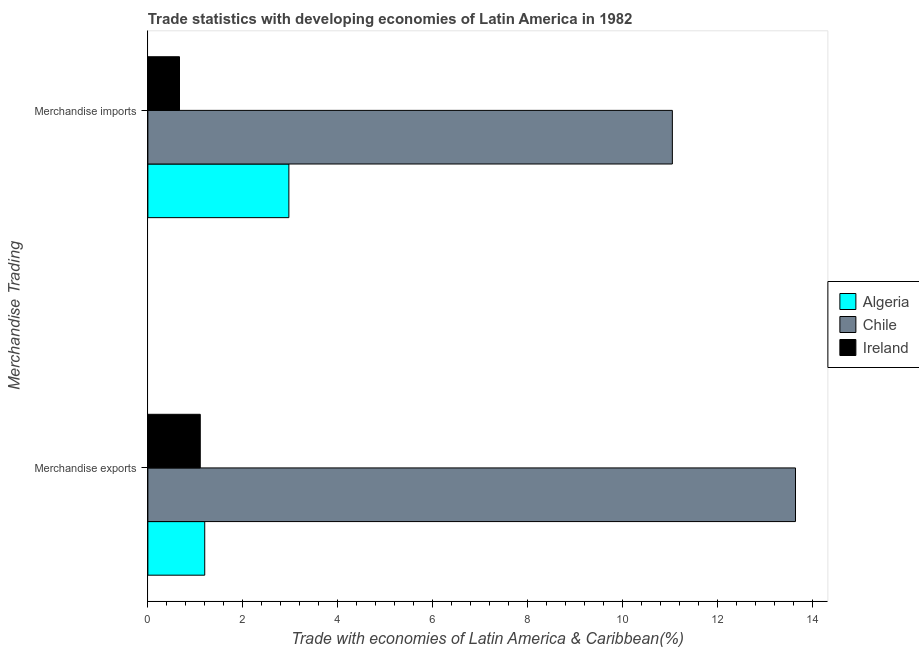How many different coloured bars are there?
Your response must be concise. 3. How many groups of bars are there?
Your answer should be very brief. 2. How many bars are there on the 1st tick from the bottom?
Provide a succinct answer. 3. What is the label of the 2nd group of bars from the top?
Give a very brief answer. Merchandise exports. What is the merchandise imports in Chile?
Your answer should be very brief. 11.05. Across all countries, what is the maximum merchandise exports?
Provide a succinct answer. 13.65. Across all countries, what is the minimum merchandise imports?
Give a very brief answer. 0.67. In which country was the merchandise exports minimum?
Offer a very short reply. Ireland. What is the total merchandise exports in the graph?
Ensure brevity in your answer.  15.95. What is the difference between the merchandise imports in Algeria and that in Chile?
Make the answer very short. -8.08. What is the difference between the merchandise imports in Algeria and the merchandise exports in Ireland?
Keep it short and to the point. 1.87. What is the average merchandise imports per country?
Your response must be concise. 4.9. What is the difference between the merchandise imports and merchandise exports in Ireland?
Provide a succinct answer. -0.44. What is the ratio of the merchandise exports in Chile to that in Ireland?
Make the answer very short. 12.36. What does the 1st bar from the top in Merchandise imports represents?
Keep it short and to the point. Ireland. What does the 3rd bar from the bottom in Merchandise imports represents?
Keep it short and to the point. Ireland. How many bars are there?
Give a very brief answer. 6. Are all the bars in the graph horizontal?
Your answer should be compact. Yes. Does the graph contain grids?
Ensure brevity in your answer.  No. Where does the legend appear in the graph?
Offer a very short reply. Center right. How many legend labels are there?
Keep it short and to the point. 3. What is the title of the graph?
Offer a very short reply. Trade statistics with developing economies of Latin America in 1982. Does "St. Vincent and the Grenadines" appear as one of the legend labels in the graph?
Give a very brief answer. No. What is the label or title of the X-axis?
Offer a very short reply. Trade with economies of Latin America & Caribbean(%). What is the label or title of the Y-axis?
Give a very brief answer. Merchandise Trading. What is the Trade with economies of Latin America & Caribbean(%) of Algeria in Merchandise exports?
Offer a very short reply. 1.2. What is the Trade with economies of Latin America & Caribbean(%) in Chile in Merchandise exports?
Provide a succinct answer. 13.65. What is the Trade with economies of Latin America & Caribbean(%) of Ireland in Merchandise exports?
Offer a terse response. 1.1. What is the Trade with economies of Latin America & Caribbean(%) in Algeria in Merchandise imports?
Your response must be concise. 2.97. What is the Trade with economies of Latin America & Caribbean(%) in Chile in Merchandise imports?
Give a very brief answer. 11.05. What is the Trade with economies of Latin America & Caribbean(%) of Ireland in Merchandise imports?
Offer a terse response. 0.67. Across all Merchandise Trading, what is the maximum Trade with economies of Latin America & Caribbean(%) of Algeria?
Keep it short and to the point. 2.97. Across all Merchandise Trading, what is the maximum Trade with economies of Latin America & Caribbean(%) in Chile?
Give a very brief answer. 13.65. Across all Merchandise Trading, what is the maximum Trade with economies of Latin America & Caribbean(%) in Ireland?
Offer a very short reply. 1.1. Across all Merchandise Trading, what is the minimum Trade with economies of Latin America & Caribbean(%) of Algeria?
Your answer should be very brief. 1.2. Across all Merchandise Trading, what is the minimum Trade with economies of Latin America & Caribbean(%) of Chile?
Provide a short and direct response. 11.05. Across all Merchandise Trading, what is the minimum Trade with economies of Latin America & Caribbean(%) of Ireland?
Offer a terse response. 0.67. What is the total Trade with economies of Latin America & Caribbean(%) of Algeria in the graph?
Provide a succinct answer. 4.17. What is the total Trade with economies of Latin America & Caribbean(%) in Chile in the graph?
Your answer should be very brief. 24.7. What is the total Trade with economies of Latin America & Caribbean(%) of Ireland in the graph?
Give a very brief answer. 1.77. What is the difference between the Trade with economies of Latin America & Caribbean(%) of Algeria in Merchandise exports and that in Merchandise imports?
Provide a short and direct response. -1.77. What is the difference between the Trade with economies of Latin America & Caribbean(%) in Chile in Merchandise exports and that in Merchandise imports?
Your response must be concise. 2.6. What is the difference between the Trade with economies of Latin America & Caribbean(%) in Ireland in Merchandise exports and that in Merchandise imports?
Ensure brevity in your answer.  0.44. What is the difference between the Trade with economies of Latin America & Caribbean(%) of Algeria in Merchandise exports and the Trade with economies of Latin America & Caribbean(%) of Chile in Merchandise imports?
Your response must be concise. -9.86. What is the difference between the Trade with economies of Latin America & Caribbean(%) in Algeria in Merchandise exports and the Trade with economies of Latin America & Caribbean(%) in Ireland in Merchandise imports?
Give a very brief answer. 0.53. What is the difference between the Trade with economies of Latin America & Caribbean(%) of Chile in Merchandise exports and the Trade with economies of Latin America & Caribbean(%) of Ireland in Merchandise imports?
Your response must be concise. 12.98. What is the average Trade with economies of Latin America & Caribbean(%) of Algeria per Merchandise Trading?
Your answer should be compact. 2.09. What is the average Trade with economies of Latin America & Caribbean(%) of Chile per Merchandise Trading?
Offer a terse response. 12.35. What is the average Trade with economies of Latin America & Caribbean(%) in Ireland per Merchandise Trading?
Your answer should be compact. 0.89. What is the difference between the Trade with economies of Latin America & Caribbean(%) in Algeria and Trade with economies of Latin America & Caribbean(%) in Chile in Merchandise exports?
Offer a terse response. -12.45. What is the difference between the Trade with economies of Latin America & Caribbean(%) in Algeria and Trade with economies of Latin America & Caribbean(%) in Ireland in Merchandise exports?
Your response must be concise. 0.09. What is the difference between the Trade with economies of Latin America & Caribbean(%) of Chile and Trade with economies of Latin America & Caribbean(%) of Ireland in Merchandise exports?
Give a very brief answer. 12.55. What is the difference between the Trade with economies of Latin America & Caribbean(%) in Algeria and Trade with economies of Latin America & Caribbean(%) in Chile in Merchandise imports?
Offer a terse response. -8.08. What is the difference between the Trade with economies of Latin America & Caribbean(%) in Algeria and Trade with economies of Latin America & Caribbean(%) in Ireland in Merchandise imports?
Give a very brief answer. 2.31. What is the difference between the Trade with economies of Latin America & Caribbean(%) of Chile and Trade with economies of Latin America & Caribbean(%) of Ireland in Merchandise imports?
Provide a short and direct response. 10.39. What is the ratio of the Trade with economies of Latin America & Caribbean(%) in Algeria in Merchandise exports to that in Merchandise imports?
Provide a short and direct response. 0.4. What is the ratio of the Trade with economies of Latin America & Caribbean(%) of Chile in Merchandise exports to that in Merchandise imports?
Give a very brief answer. 1.23. What is the ratio of the Trade with economies of Latin America & Caribbean(%) in Ireland in Merchandise exports to that in Merchandise imports?
Offer a terse response. 1.66. What is the difference between the highest and the second highest Trade with economies of Latin America & Caribbean(%) of Algeria?
Ensure brevity in your answer.  1.77. What is the difference between the highest and the second highest Trade with economies of Latin America & Caribbean(%) in Chile?
Make the answer very short. 2.6. What is the difference between the highest and the second highest Trade with economies of Latin America & Caribbean(%) of Ireland?
Your answer should be compact. 0.44. What is the difference between the highest and the lowest Trade with economies of Latin America & Caribbean(%) of Algeria?
Provide a short and direct response. 1.77. What is the difference between the highest and the lowest Trade with economies of Latin America & Caribbean(%) of Chile?
Provide a succinct answer. 2.6. What is the difference between the highest and the lowest Trade with economies of Latin America & Caribbean(%) in Ireland?
Your response must be concise. 0.44. 